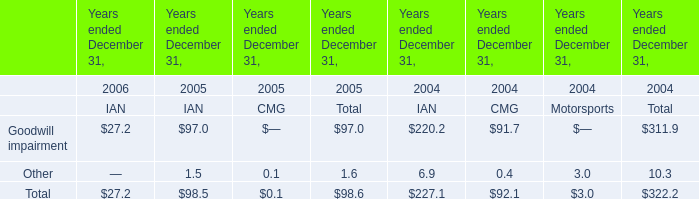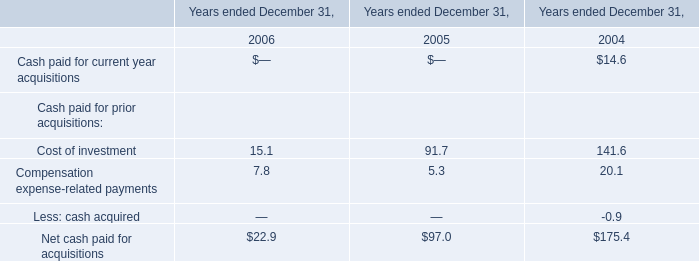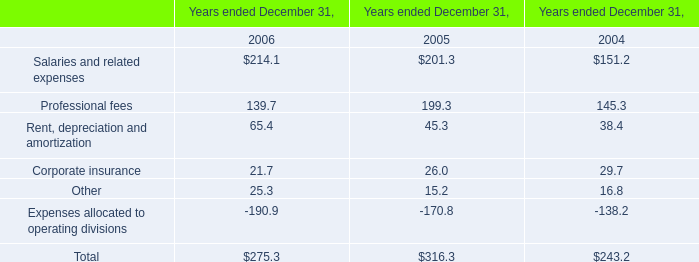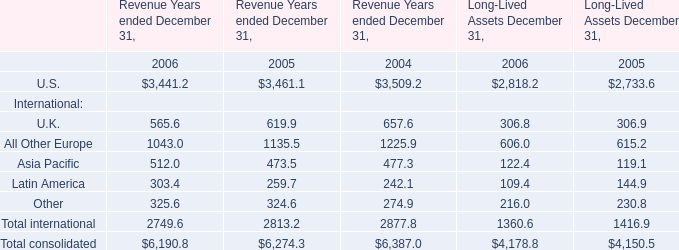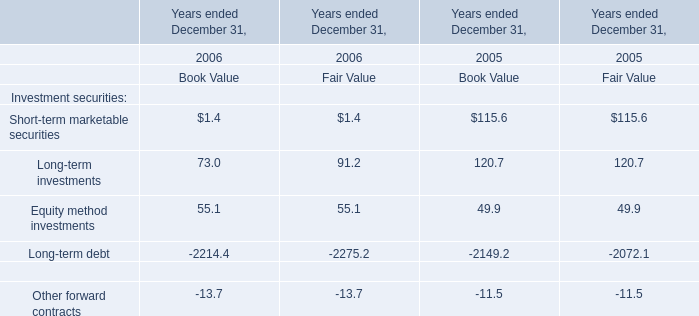What was the average value of Short-term marketable securities, Long-term investments, Equity method investments in 2006 for book value? 
Computations: (((1.4 + 73) + 55.1) / 3)
Answer: 43.16667. 